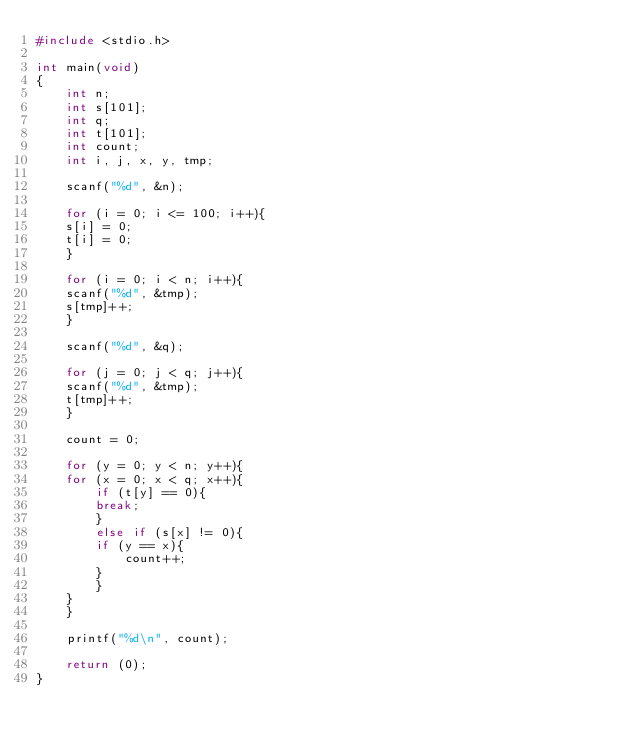<code> <loc_0><loc_0><loc_500><loc_500><_C_>#include <stdio.h>

int main(void)
{
    int n;
    int s[101];
    int q;
    int t[101];
    int count;
    int i, j, x, y, tmp;

    scanf("%d", &n);

    for (i = 0; i <= 100; i++){
	s[i] = 0;
	t[i] = 0;
    }

    for (i = 0; i < n; i++){
	scanf("%d", &tmp);
	s[tmp]++;
    }

    scanf("%d", &q);

    for (j = 0; j < q; j++){
	scanf("%d", &tmp);
	t[tmp]++;
    }

    count = 0;

    for (y = 0; y < n; y++){
	for (x = 0; x < q; x++){
	    if (t[y] == 0){
		break;
	    }
	    else if (s[x] != 0){
		if (y == x){
		    count++;
		}
	    }
	}
    }

    printf("%d\n", count);

    return (0);
}</code> 